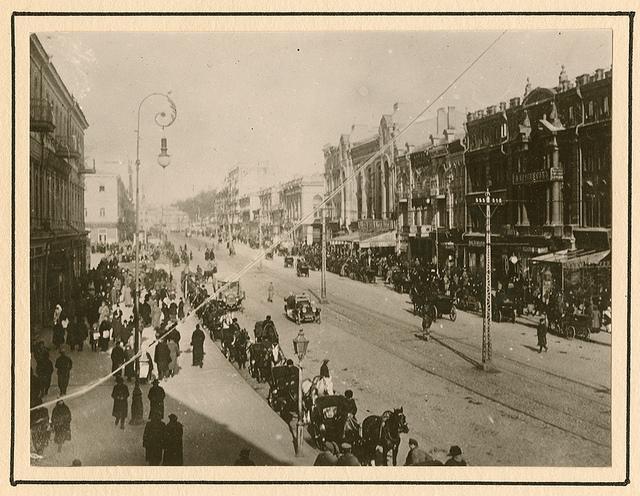How many benches are there?
Give a very brief answer. 0. 